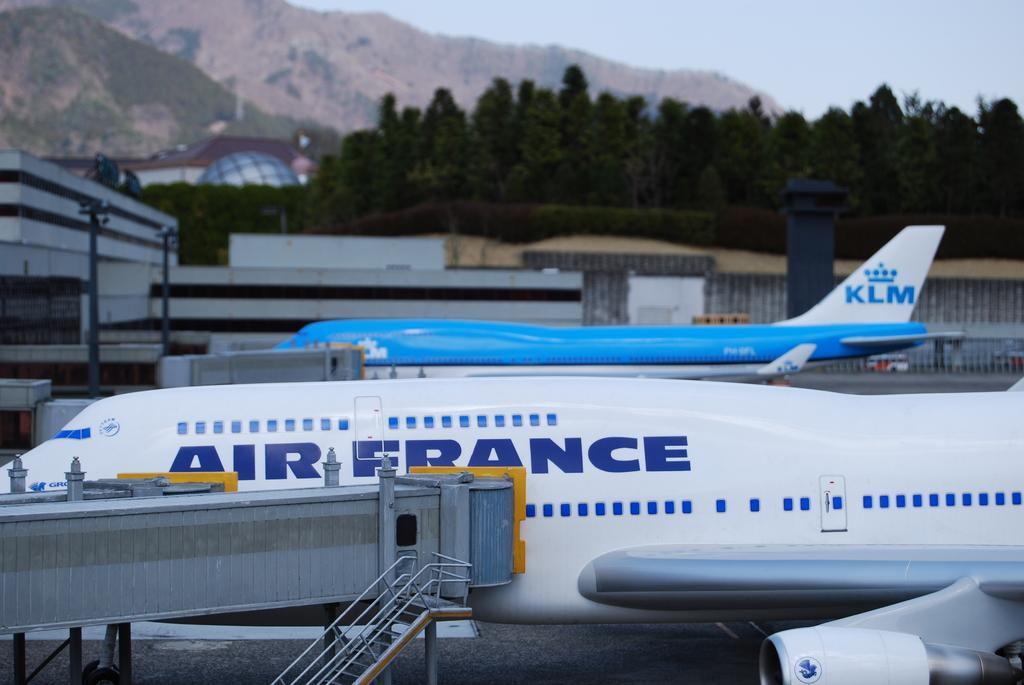<image>
Render a clear and concise summary of the photo. A two airplanes which one is Air France and the other is KLM lined up on the tarmac. 